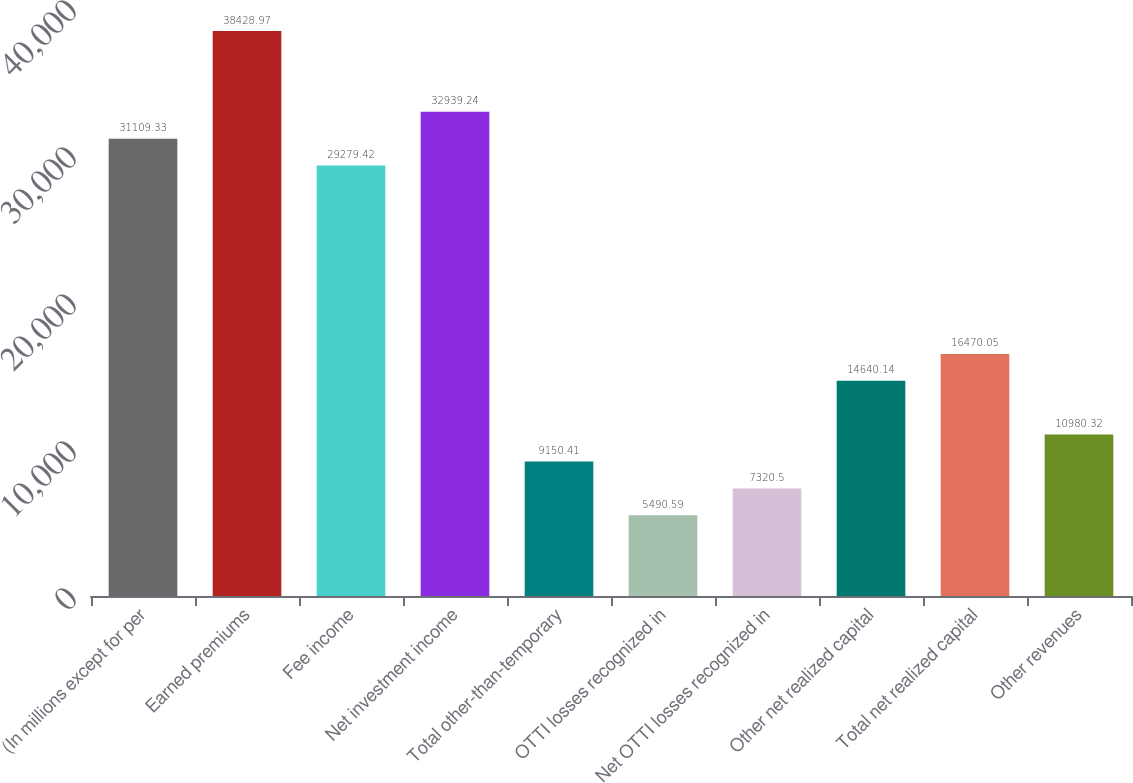Convert chart to OTSL. <chart><loc_0><loc_0><loc_500><loc_500><bar_chart><fcel>(In millions except for per<fcel>Earned premiums<fcel>Fee income<fcel>Net investment income<fcel>Total other-than-temporary<fcel>OTTI losses recognized in<fcel>Net OTTI losses recognized in<fcel>Other net realized capital<fcel>Total net realized capital<fcel>Other revenues<nl><fcel>31109.3<fcel>38429<fcel>29279.4<fcel>32939.2<fcel>9150.41<fcel>5490.59<fcel>7320.5<fcel>14640.1<fcel>16470<fcel>10980.3<nl></chart> 